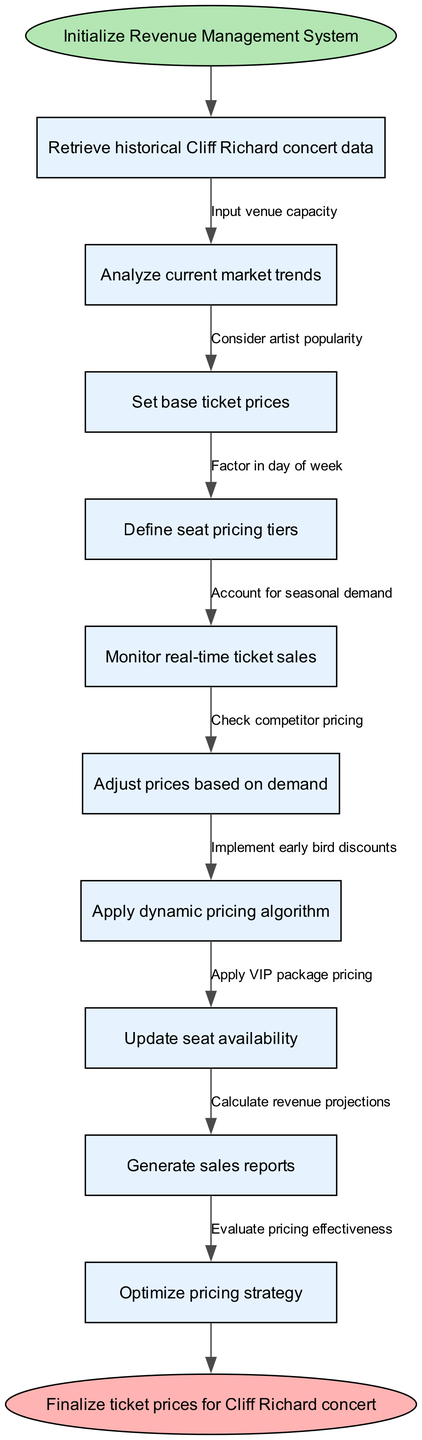What is the starting point of the flowchart? The starting point is indicated as "Initialize Revenue Management System," which is the first node in the diagram.
Answer: Initialize Revenue Management System How many nodes are there in the diagram? The diagram contains a total of 11 nodes, including the start and end nodes along with the main process steps.
Answer: 11 What is the final step before concluding the flow? The last step before reaching the end is "Optimize pricing strategy," which is the last main processing node before finalizing prices.
Answer: Optimize pricing strategy Which node connects to "Define seat pricing tiers"? "Set base ticket prices" connects to "Define seat pricing tiers," as it is the preceding step in the flow.
Answer: Set base ticket prices What factors influence the adjustment of pricing based on demand? The edges leading to "Adjust prices based on demand" include artist popularity, day of week, and seasonal demand, among others.
Answer: Artist popularity, day of week, seasonal demand How many edges are outgoing from the "Monitor real-time ticket sales" node? There are no outgoing edges from the "Monitor real-time ticket sales" node in the flowchart, which indicates it leads directly to the next node without any additional connections.
Answer: 0 Which node is reached after applying the dynamic pricing algorithm? The next node after applying the dynamic pricing algorithm is "Update seat availability," indicating a direct flow.
Answer: Update seat availability What step occurs directly after "Retrieve historical Cliff Richard concert data"? The step that follows is "Analyze current market trends," which is the next processing action in the flow.
Answer: Analyze current market trends What is the significance of the edges in the flowchart? The edges represent the relationships and conditions under which the system flows from one node to another, detailing crucial decision points and factors to consider.
Answer: Relationships and conditions 